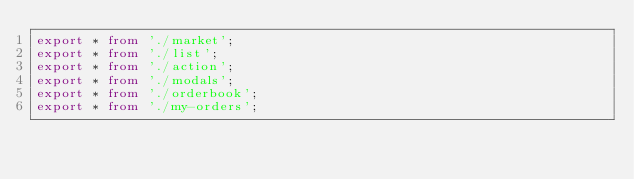Convert code to text. <code><loc_0><loc_0><loc_500><loc_500><_TypeScript_>export * from './market';
export * from './list';
export * from './action';
export * from './modals';
export * from './orderbook';
export * from './my-orders';
</code> 